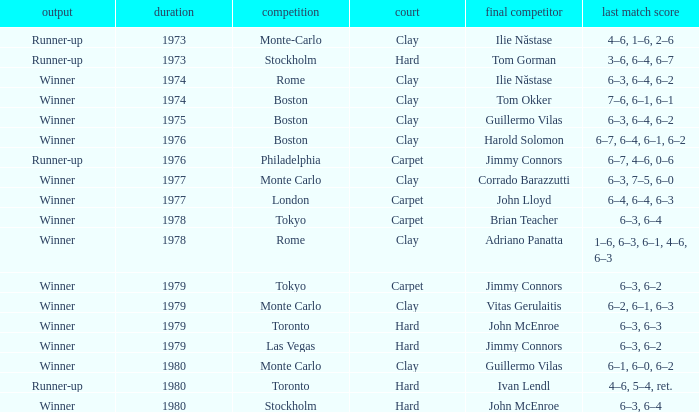Name the surface for philadelphia Carpet. 